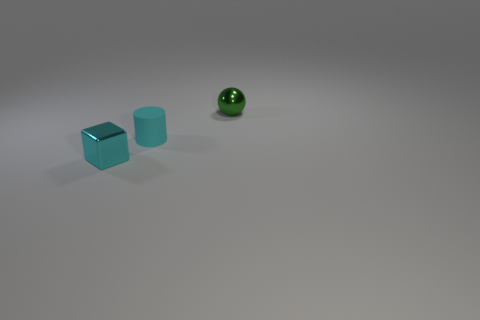Add 3 tiny balls. How many objects exist? 6 Subtract all cylinders. How many objects are left? 2 Subtract 0 gray cubes. How many objects are left? 3 Subtract all small spheres. Subtract all cylinders. How many objects are left? 1 Add 1 green balls. How many green balls are left? 2 Add 1 tiny rubber objects. How many tiny rubber objects exist? 2 